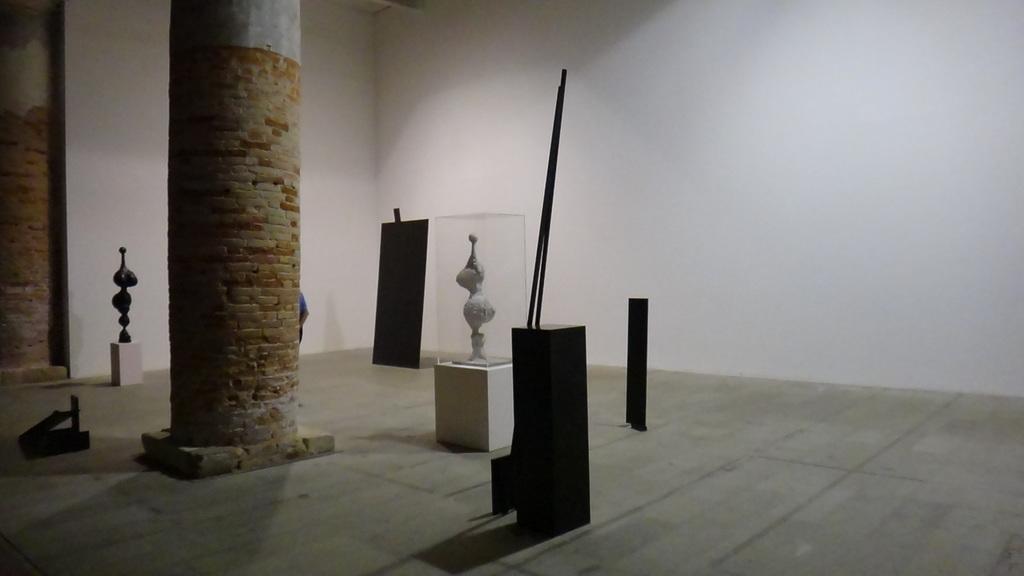In one or two sentences, can you explain what this image depicts? In the picture we can see a hall with two pillars and near it, we can see some stones and some things are placed on it. 